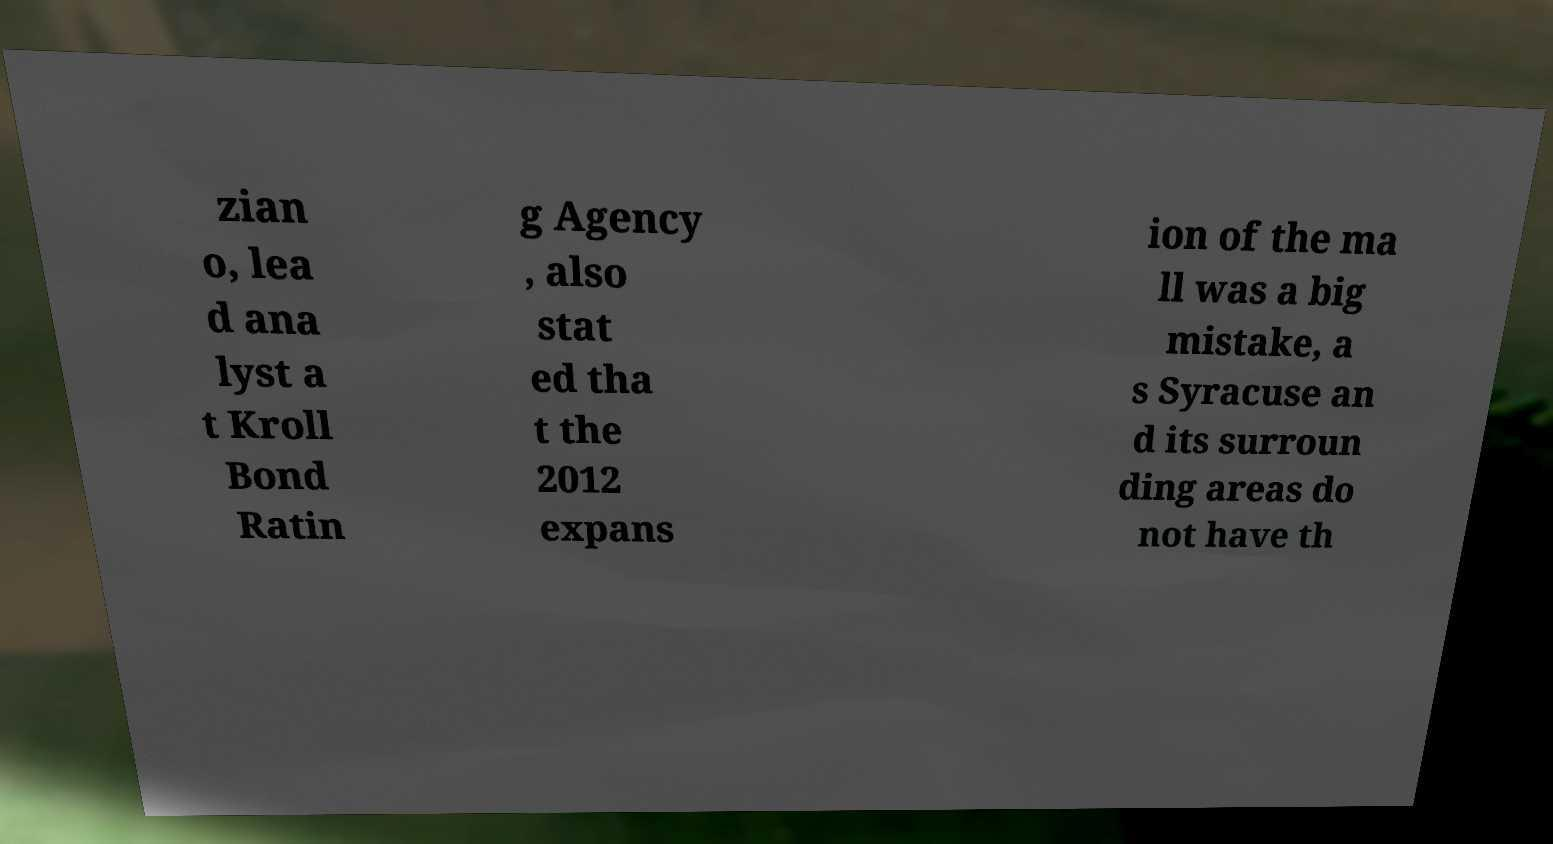Please identify and transcribe the text found in this image. zian o, lea d ana lyst a t Kroll Bond Ratin g Agency , also stat ed tha t the 2012 expans ion of the ma ll was a big mistake, a s Syracuse an d its surroun ding areas do not have th 